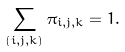Convert formula to latex. <formula><loc_0><loc_0><loc_500><loc_500>\sum _ { ( i , j , k ) } \pi _ { i , j , k } = 1 .</formula> 